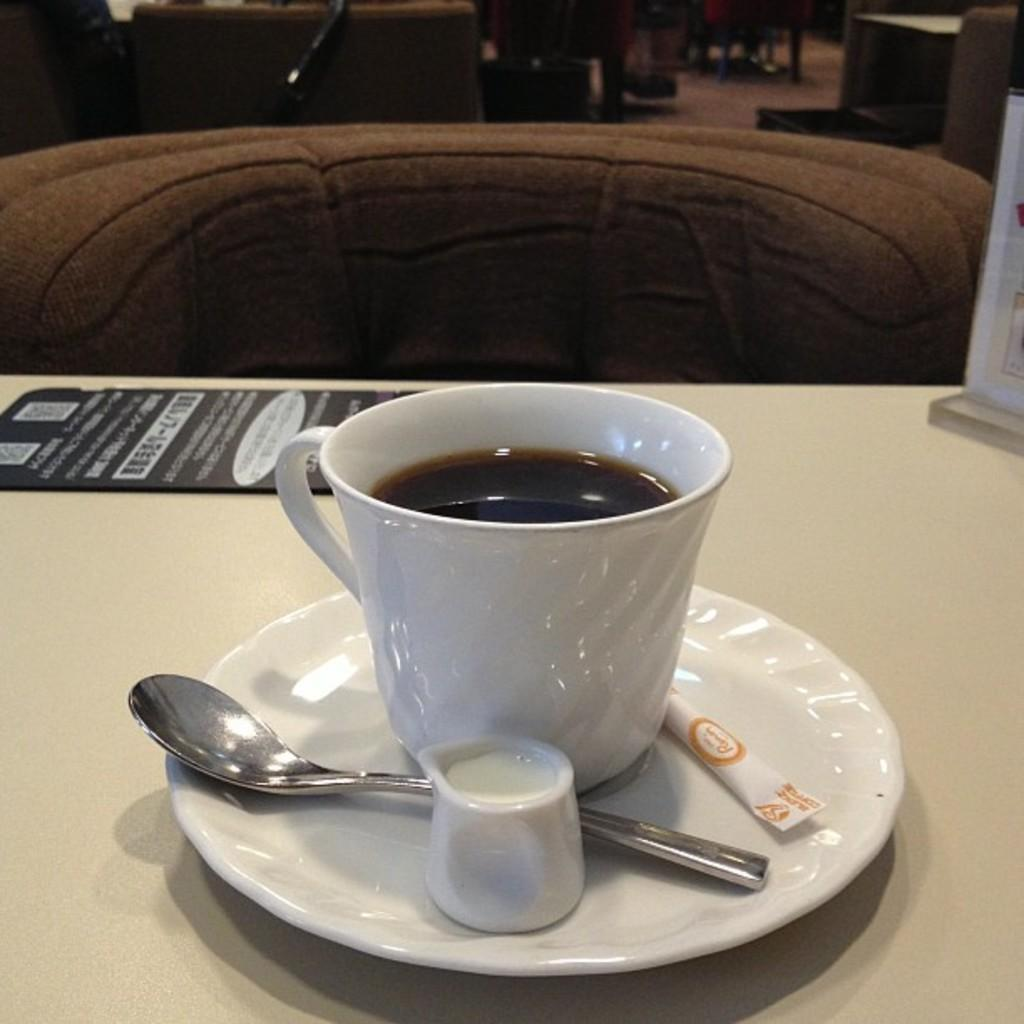What is in the cup that is visible in the image? There is a cup of coffee in the image. What is the cup of coffee resting on? The cup of coffee is on a saucer. What utensil is present in the image? There is a spoon in the image. Where are the cup of coffee, saucer, and spoon located? They are placed on a table. What type of printed material is in the image? There is a pamphlet in the image. What type of needle is used to sew the pump in the image? There is no needle or pump present in the image; it features a cup of coffee, saucer, spoon, table, and pamphlet. 